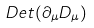<formula> <loc_0><loc_0><loc_500><loc_500>D e t ( \partial _ { \mu } D _ { \mu } )</formula> 